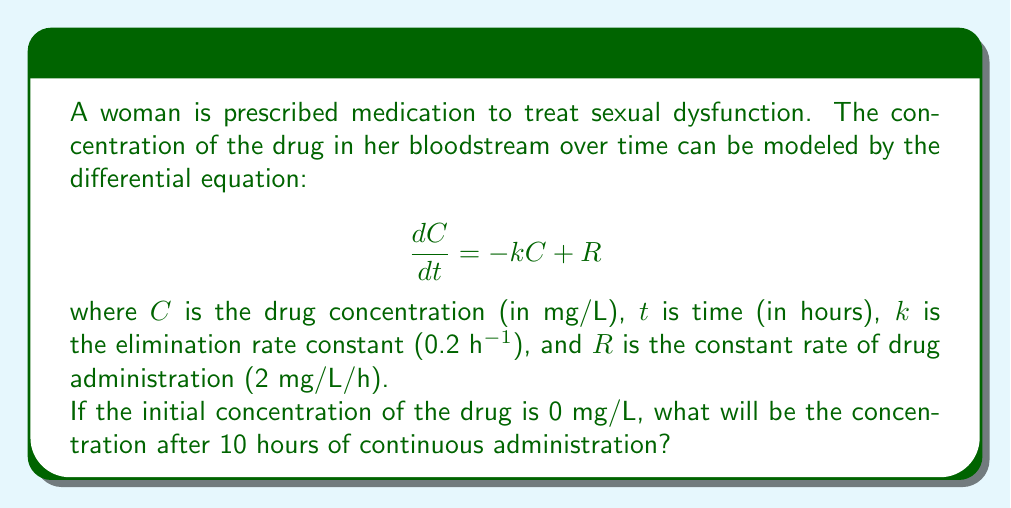What is the answer to this math problem? To solve this problem, we follow these steps:

1) The given differential equation is first-order linear:
   $$\frac{dC}{dt} + kC = R$$

2) The general solution for this type of equation is:
   $$C(t) = Ce^{-kt} + \frac{R}{k}(1-e^{-kt})$$
   where $C$ is a constant determined by initial conditions.

3) Given initial condition $C(0) = 0$, we can find $C$:
   $$0 = C + \frac{R}{k}(1-1)$$
   $$C = 0$$

4) Substituting known values ($k = 0.2$, $R = 2$, $t = 10$):
   $$C(10) = 0 \cdot e^{-0.2 \cdot 10} + \frac{2}{0.2}(1-e^{-0.2 \cdot 10})$$

5) Simplify:
   $$C(10) = 10(1-e^{-2})$$
   $$C(10) = 10(1-0.1353)$$
   $$C(10) = 8.647$$

Therefore, after 10 hours, the drug concentration will be approximately 8.647 mg/L.
Answer: 8.647 mg/L 